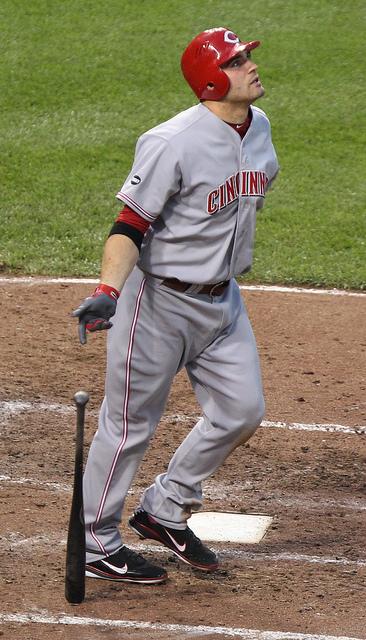What team does this person play for?
Short answer required. Cincinnati. What team does he play for?
Concise answer only. Cincinnati. What expression is on the man's face?
Concise answer only. Happy. What is the mans cap color?
Give a very brief answer. Red. Is he holding the bat?
Concise answer only. No. 